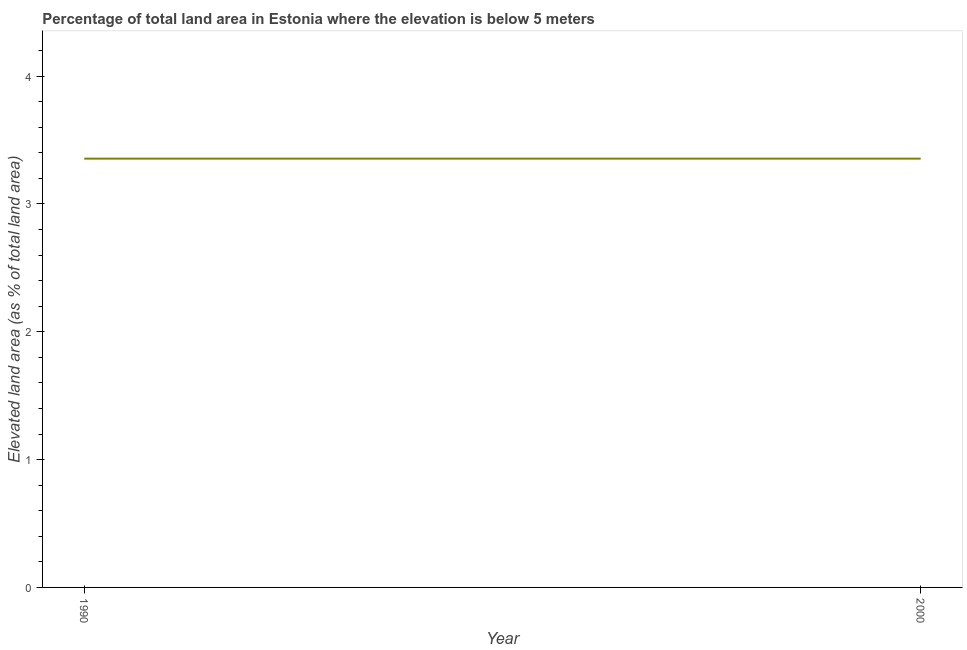What is the total elevated land area in 2000?
Offer a very short reply. 3.35. Across all years, what is the maximum total elevated land area?
Give a very brief answer. 3.35. Across all years, what is the minimum total elevated land area?
Your answer should be compact. 3.35. What is the sum of the total elevated land area?
Make the answer very short. 6.71. What is the difference between the total elevated land area in 1990 and 2000?
Ensure brevity in your answer.  0. What is the average total elevated land area per year?
Provide a short and direct response. 3.35. What is the median total elevated land area?
Ensure brevity in your answer.  3.35. In how many years, is the total elevated land area greater than the average total elevated land area taken over all years?
Keep it short and to the point. 0. How many lines are there?
Give a very brief answer. 1. How many years are there in the graph?
Offer a terse response. 2. What is the difference between two consecutive major ticks on the Y-axis?
Offer a very short reply. 1. Does the graph contain any zero values?
Your response must be concise. No. Does the graph contain grids?
Offer a terse response. No. What is the title of the graph?
Provide a succinct answer. Percentage of total land area in Estonia where the elevation is below 5 meters. What is the label or title of the Y-axis?
Your answer should be very brief. Elevated land area (as % of total land area). What is the Elevated land area (as % of total land area) of 1990?
Provide a short and direct response. 3.35. What is the Elevated land area (as % of total land area) of 2000?
Offer a terse response. 3.35. What is the difference between the Elevated land area (as % of total land area) in 1990 and 2000?
Provide a succinct answer. 0. 